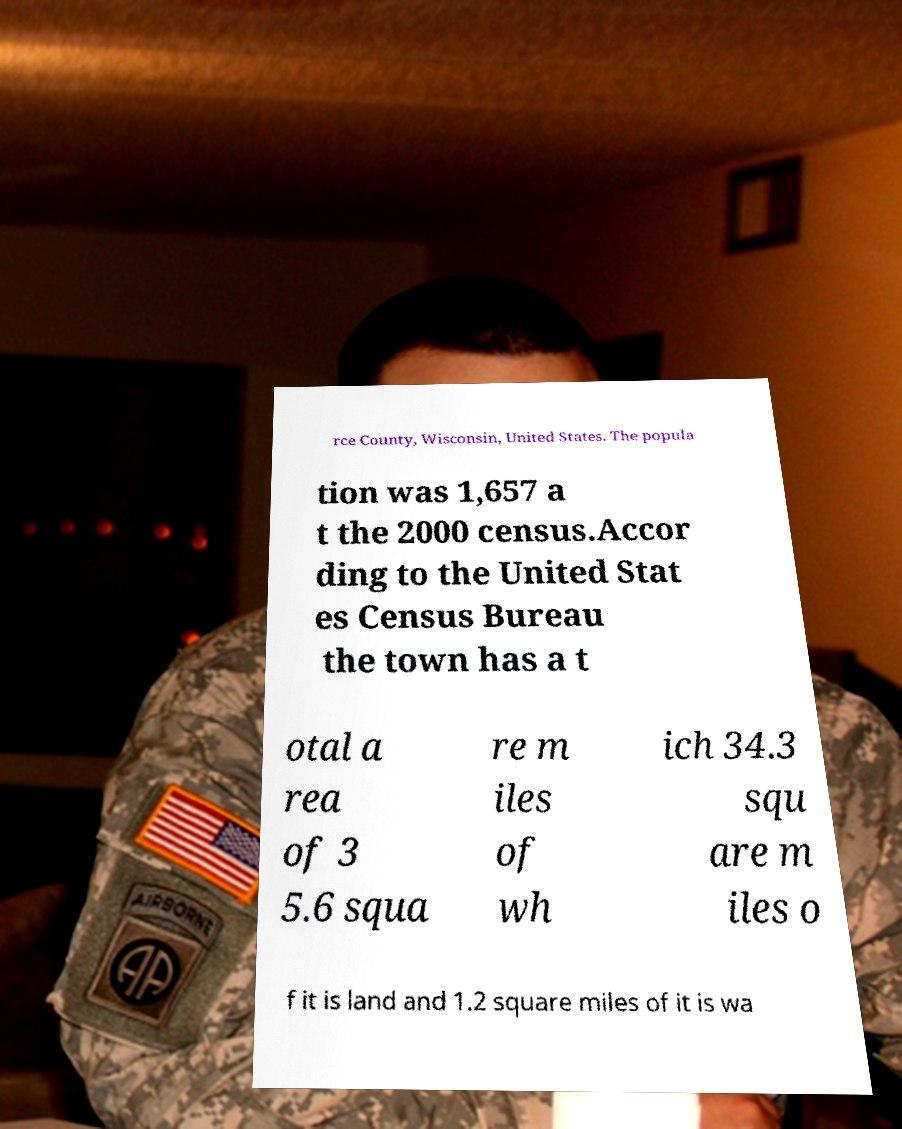Could you extract and type out the text from this image? rce County, Wisconsin, United States. The popula tion was 1,657 a t the 2000 census.Accor ding to the United Stat es Census Bureau the town has a t otal a rea of 3 5.6 squa re m iles of wh ich 34.3 squ are m iles o f it is land and 1.2 square miles of it is wa 